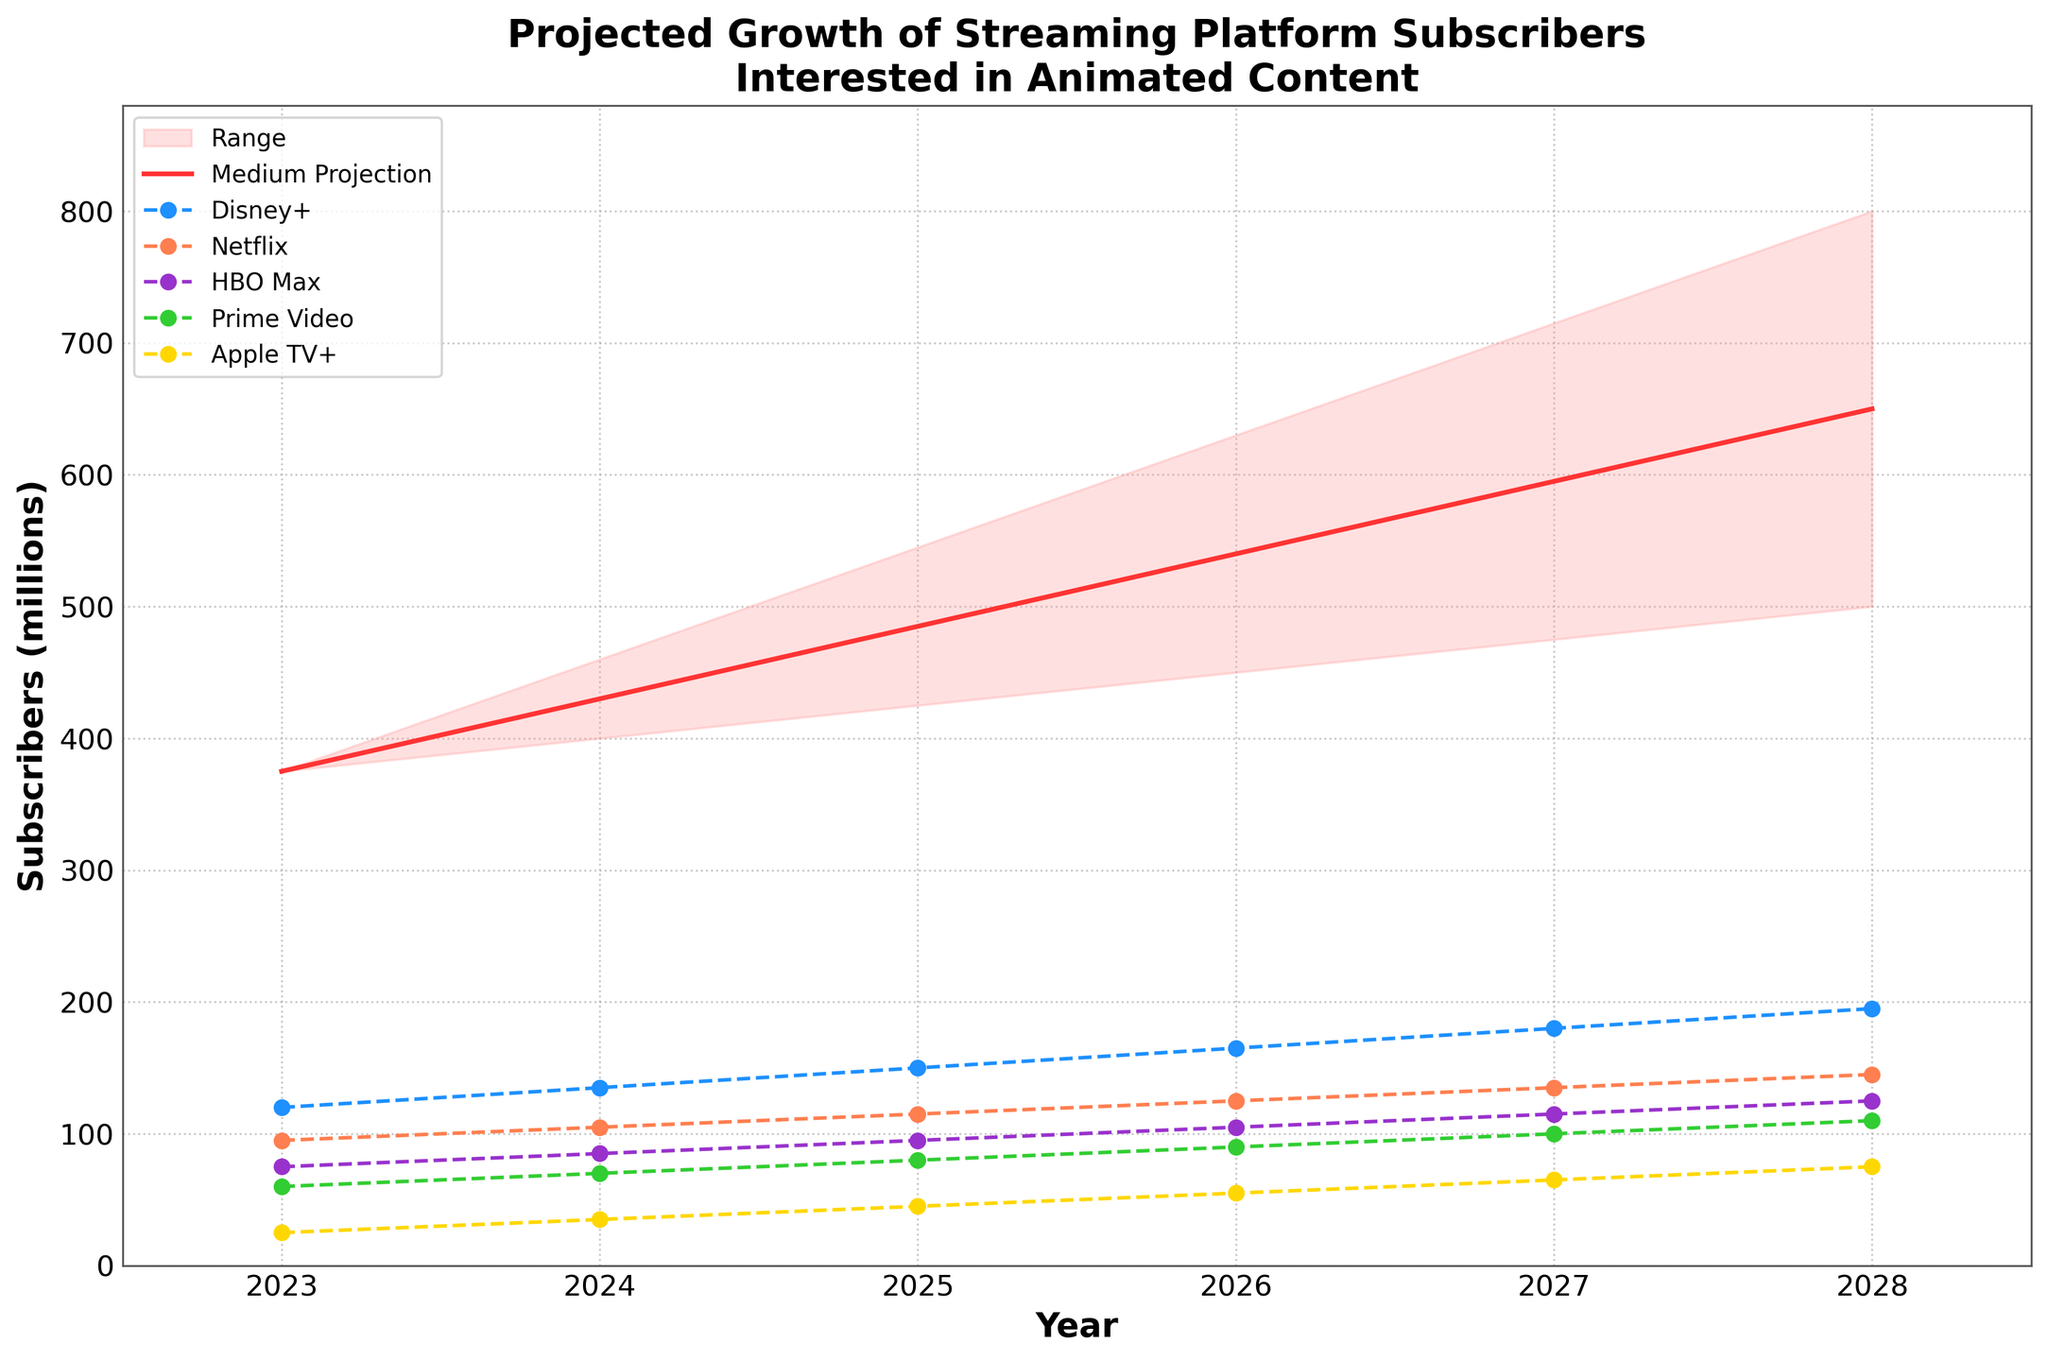What is the title of the figure? The title of the figure is displayed at the top, and it reads "Projected Growth of Streaming Platform Subscribers Interested in Animated Content".
Answer: Projected Growth of Streaming Platform Subscribers Interested in Animated Content Which platform has the highest number of subscribers in 2023? Looking at the 2023 data points on the plot, Disney+ has the highest number of subscribers, which is indicated by the blue line marker.
Answer: Disney+ What is the projected number of subscribers in 2028 for the Low, Medium, and High projections? The fan chart shows different projections in red shades. In 2028, Low (500 million), Medium (650 million), and High (800 million) values are derived from the respective shaded regions and the medium red line.
Answer: 500, 650, 800 Between which years does Prime Video experience the highest growth in subscribers? From the plot, Prime Video’s growth is represented by the green line. The steepest increase occurs between 2027 and 2028, rising from 100 million to 110 million.
Answer: 2027 to 2028 On average, how many subscribers does HBO Max have from 2023 to 2028? Add the HBO Max values from each year (75, 85, 95, 105, 115, 125), then divide by the number of years (6). Thus (75 + 85 + 95 + 105 + 115 + 125) / 6 = 100.
Answer: 100 Which year sees the smallest difference between Low and High projected subscriber numbers? The smallest difference is seen by comparing the Low and High values each year. The lowest difference is in 2023, with both values being 375 million (a difference of 0).
Answer: 2023 What year does Netflix surpass 100 million subscribers? From the orange line representing Netflix, it surpasses 100 million subscribers in 2024 where it reaches 105 million.
Answer: 2024 By how many millions do subscribers of Disney+ grow from 2023 to 2028? The Disney+ subscriber count goes from 120 million to 195 million. The increase is 195 - 120 = 75 million.
Answer: 75 What is the trend in the medium projection line from 2023 to 2028? The medium projection line rises steadily from 375 million in 2023, increasing each year to reach 650 million in 2028. This is shown by the straight red line.
Answer: Steady increase Compare the growth rates of Apple TV+ and HBO Max between 2024 and 2027. Which one grows faster? Apple TV+ grows from 35 to 65 million, an increase of 30 million. HBO Max grows from 85 to 115 million, an increase of 30 million. Both grow at the same rate.
Answer: Same rate 